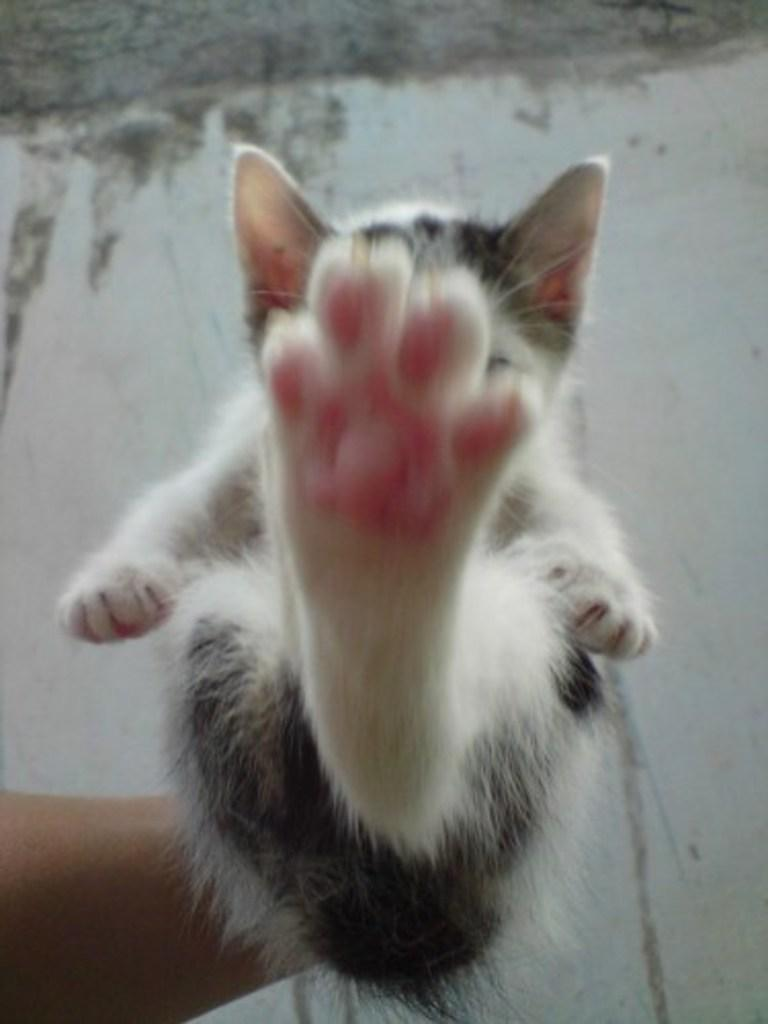Who is present in the image? There is a person in the image. What is the person holding? The person is holding a cat. Can you describe the appearance of the cat? The cat is black and white in color. What can be seen in the background of the image? There is a wall visible in the image. What is the person in the image trying to pull? There is no indication in the image that the person is trying to pull anything. 